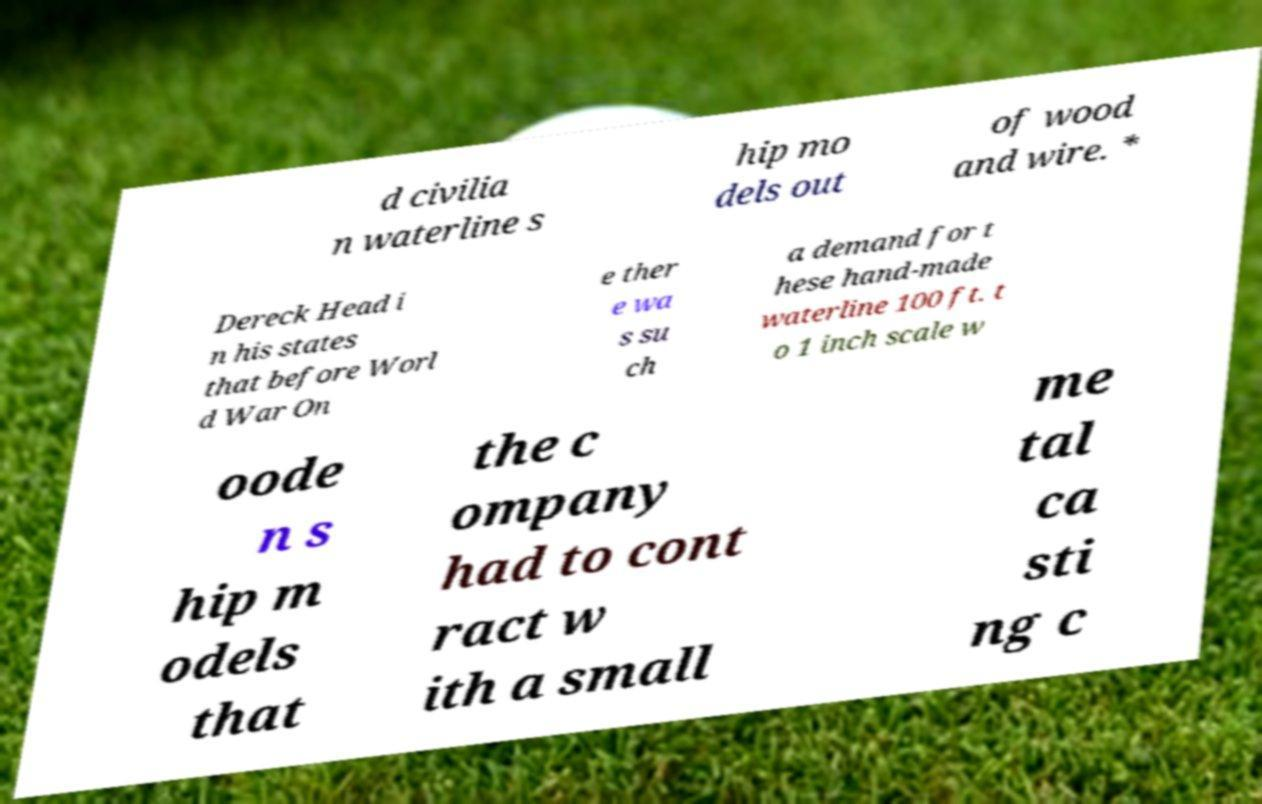Please identify and transcribe the text found in this image. d civilia n waterline s hip mo dels out of wood and wire. * Dereck Head i n his states that before Worl d War On e ther e wa s su ch a demand for t hese hand-made waterline 100 ft. t o 1 inch scale w oode n s hip m odels that the c ompany had to cont ract w ith a small me tal ca sti ng c 